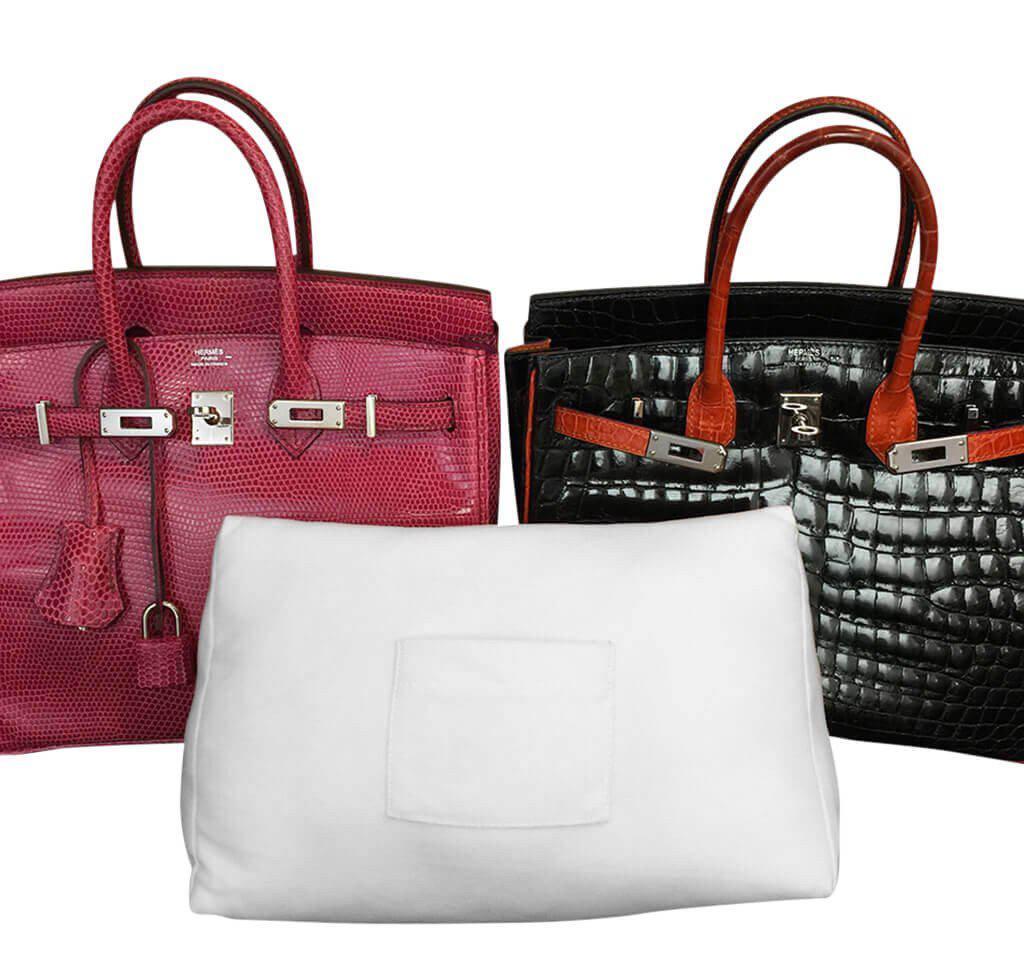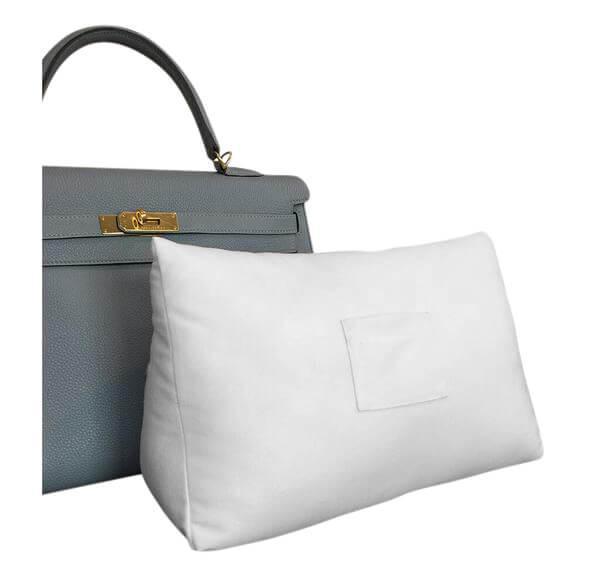The first image is the image on the left, the second image is the image on the right. Given the left and right images, does the statement "At least one image shows a dark brown bag and a golden-yellow bag behind a white pillow." hold true? Answer yes or no. No. The first image is the image on the left, the second image is the image on the right. Given the left and right images, does the statement "Each image shows two different colored handbags with double handles and metal trim sitting behind a white stuffed pillow form." hold true? Answer yes or no. No. 